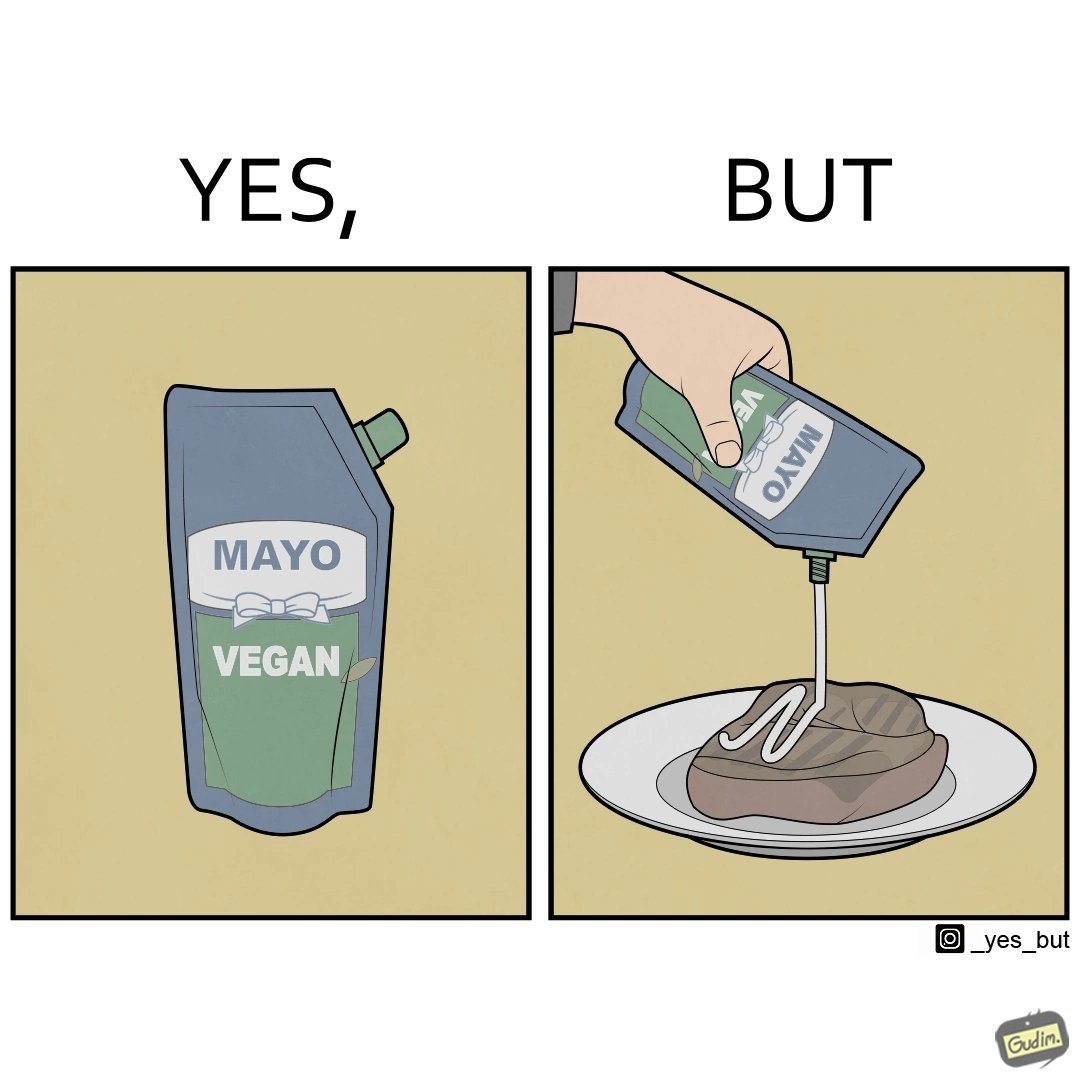Describe the satirical element in this image. The image is ironical, as vegan mayo sauce is being poured on rib steak, which is non-vegetarian. The person might as well just use normal mayo sauce instead. 